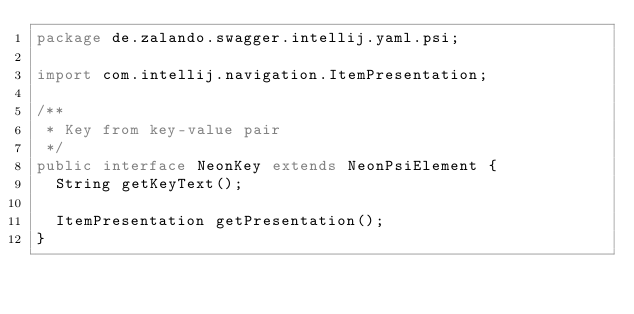<code> <loc_0><loc_0><loc_500><loc_500><_Java_>package de.zalando.swagger.intellij.yaml.psi;

import com.intellij.navigation.ItemPresentation;

/**
 * Key from key-value pair
 */
public interface NeonKey extends NeonPsiElement {
  String getKeyText();

  ItemPresentation getPresentation();
}
</code> 